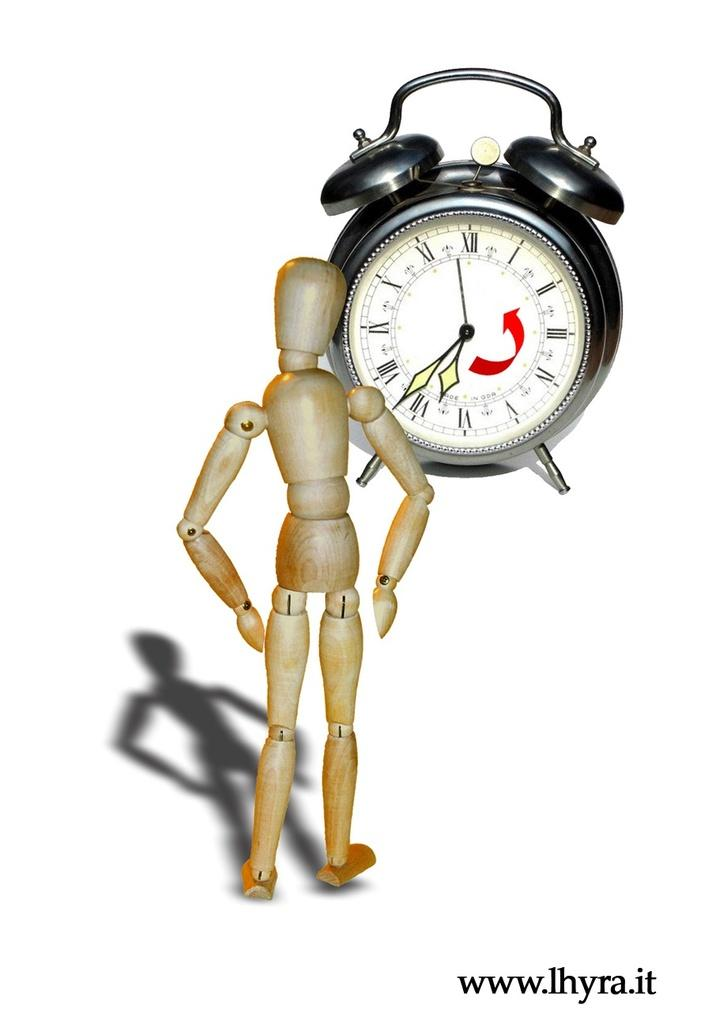<image>
Create a compact narrative representing the image presented. a wood figure next to a clock and the bottom has www.ihyra.it 